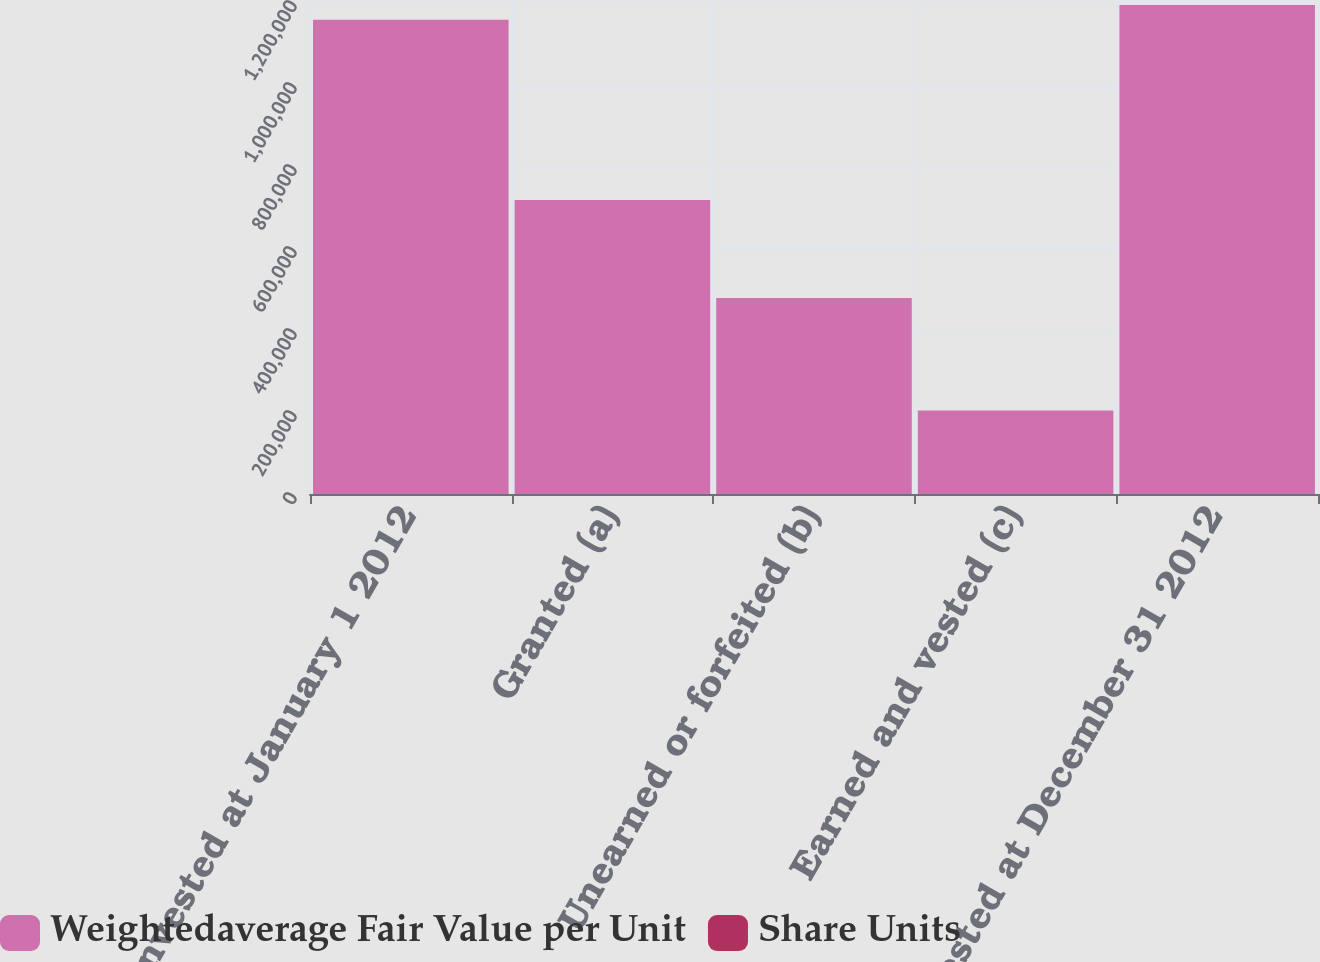Convert chart to OTSL. <chart><loc_0><loc_0><loc_500><loc_500><stacked_bar_chart><ecel><fcel>Nonvested at January 1 2012<fcel>Granted (a)<fcel>Unearned or forfeited (b)<fcel>Earned and vested (c)<fcel>Nonvested at December 31 2012<nl><fcel>Weightedaverage Fair Value per Unit<fcel>1.15683e+06<fcel>717151<fcel>477928<fcel>203567<fcel>1.19249e+06<nl><fcel>Share Units<fcel>31.7<fcel>35.68<fcel>32.04<fcel>34.01<fcel>33.56<nl></chart> 